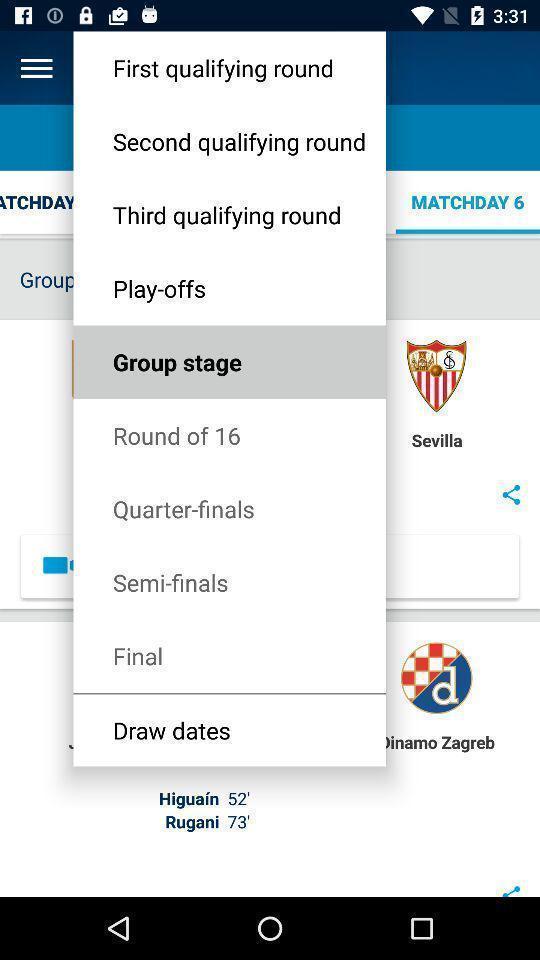Tell me about the visual elements in this screen capture. Push up displaying list of game rounds. 